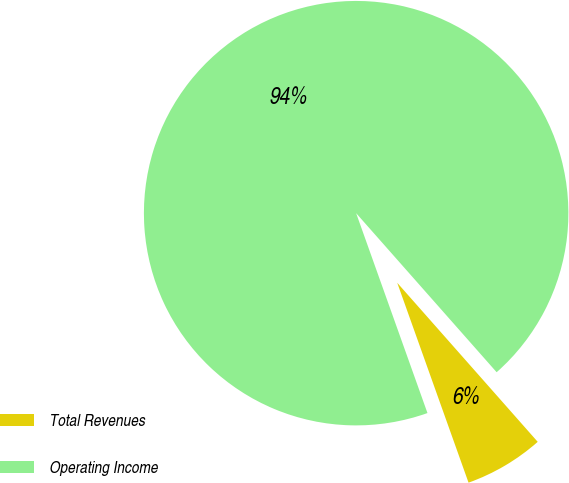Convert chart to OTSL. <chart><loc_0><loc_0><loc_500><loc_500><pie_chart><fcel>Total Revenues<fcel>Operating Income<nl><fcel>6.06%<fcel>93.94%<nl></chart> 